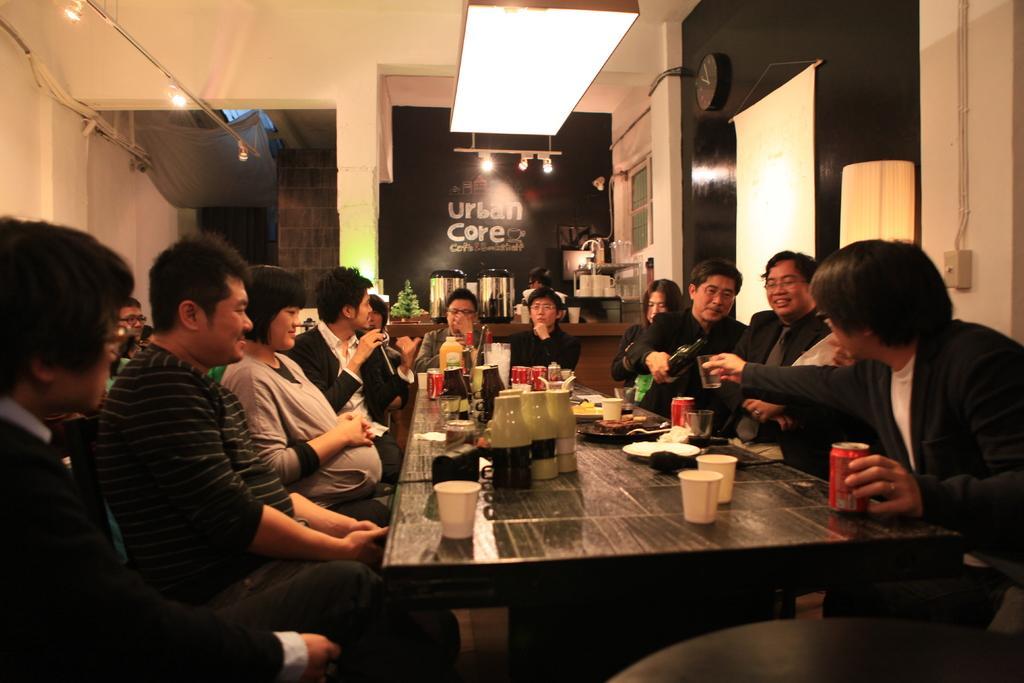Describe this image in one or two sentences. In the image we can see there are lot of people who are sitting and there is a table on which there are glasses and on plate there is a food item. 